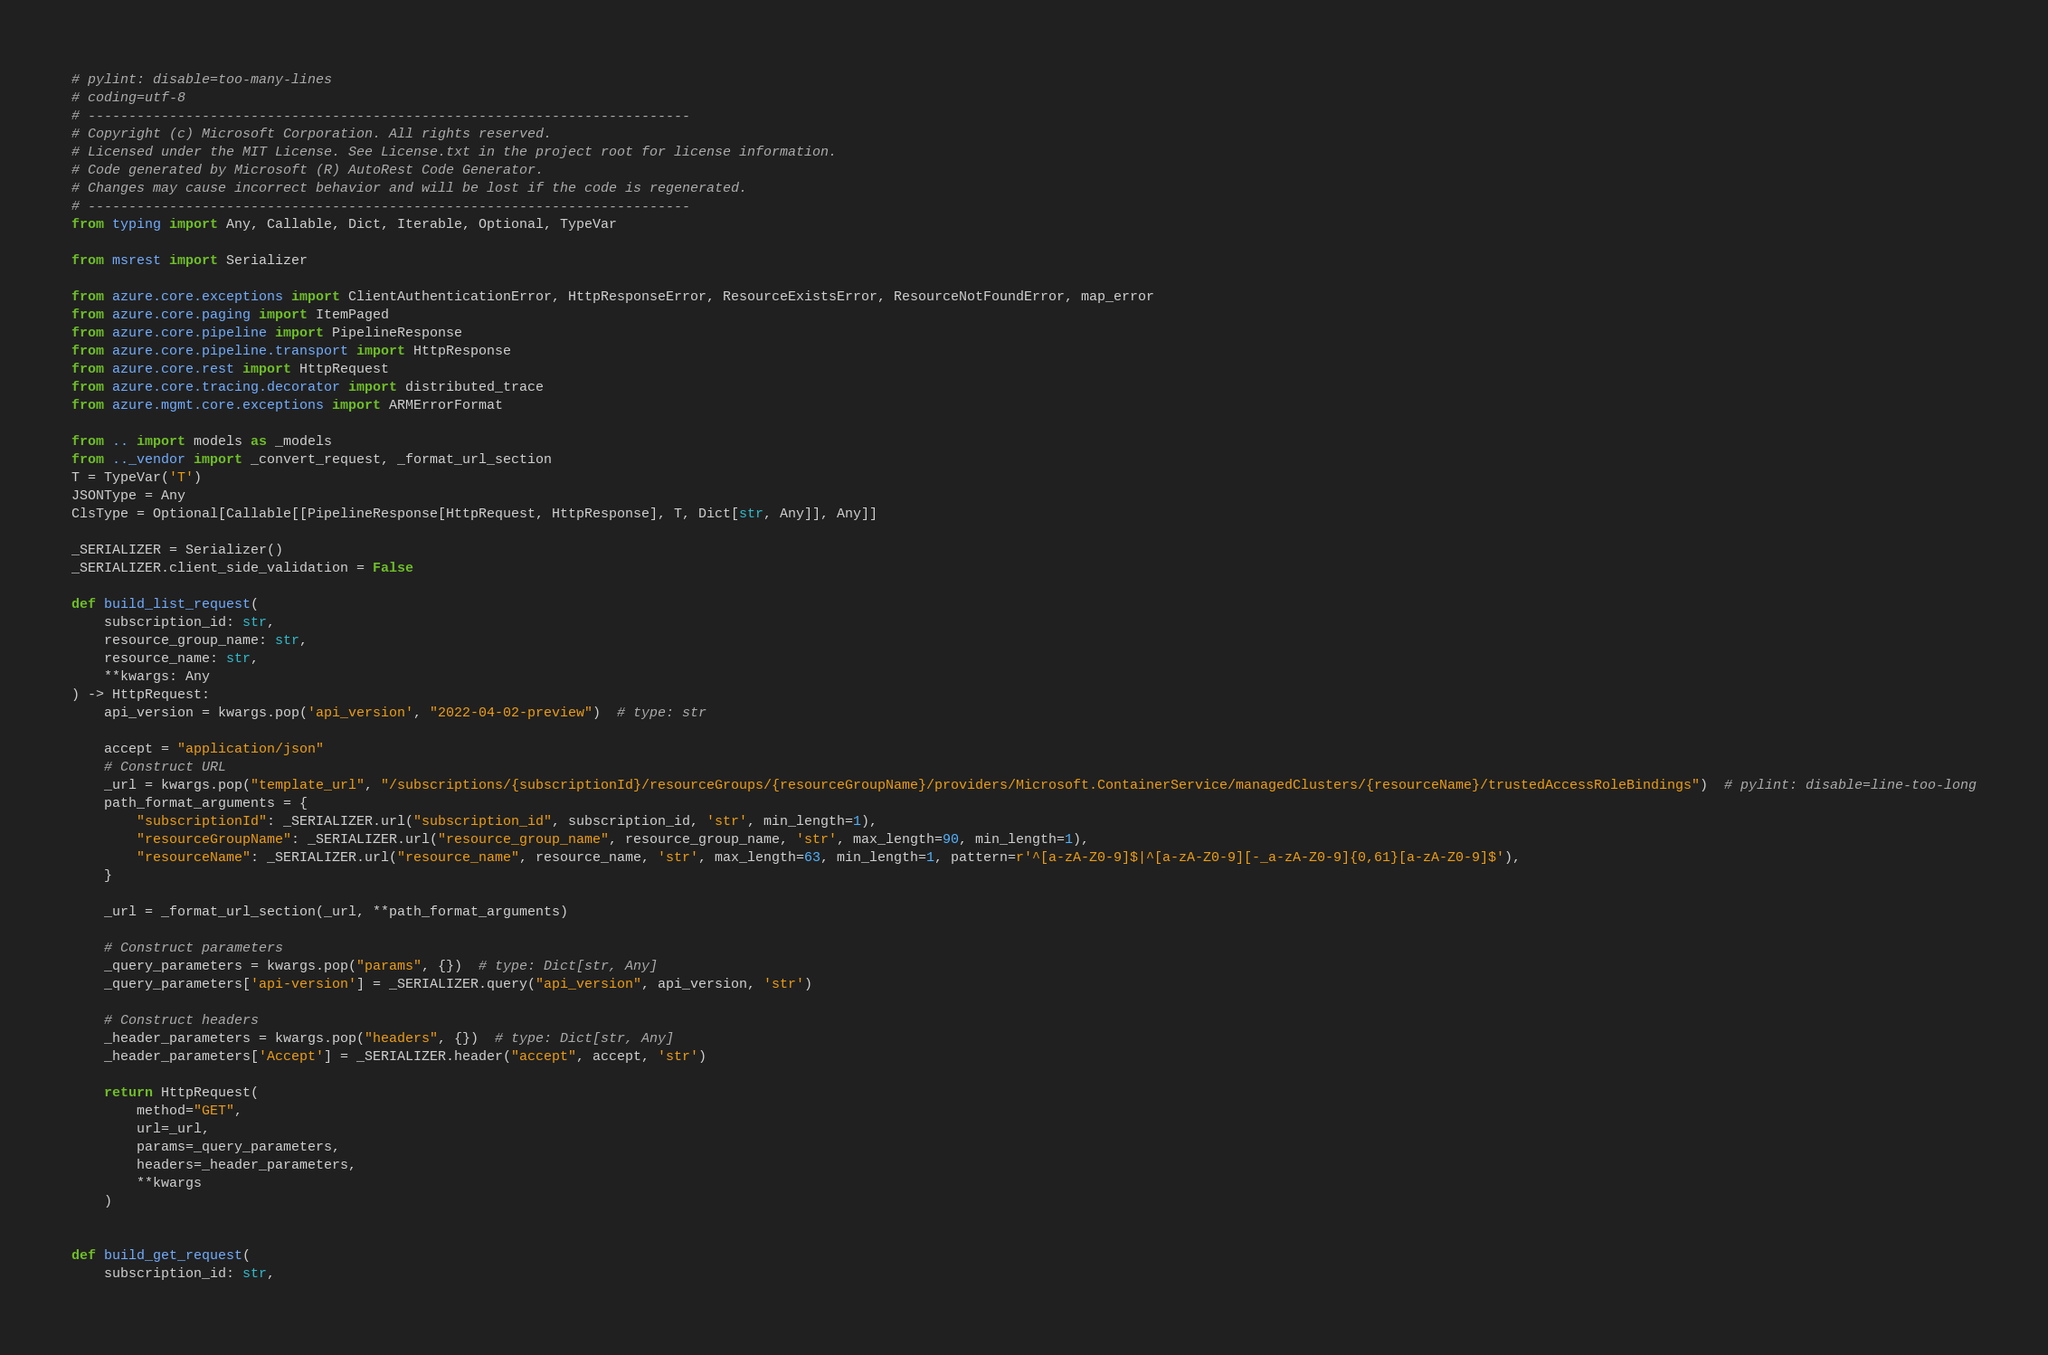Convert code to text. <code><loc_0><loc_0><loc_500><loc_500><_Python_># pylint: disable=too-many-lines
# coding=utf-8
# --------------------------------------------------------------------------
# Copyright (c) Microsoft Corporation. All rights reserved.
# Licensed under the MIT License. See License.txt in the project root for license information.
# Code generated by Microsoft (R) AutoRest Code Generator.
# Changes may cause incorrect behavior and will be lost if the code is regenerated.
# --------------------------------------------------------------------------
from typing import Any, Callable, Dict, Iterable, Optional, TypeVar

from msrest import Serializer

from azure.core.exceptions import ClientAuthenticationError, HttpResponseError, ResourceExistsError, ResourceNotFoundError, map_error
from azure.core.paging import ItemPaged
from azure.core.pipeline import PipelineResponse
from azure.core.pipeline.transport import HttpResponse
from azure.core.rest import HttpRequest
from azure.core.tracing.decorator import distributed_trace
from azure.mgmt.core.exceptions import ARMErrorFormat

from .. import models as _models
from .._vendor import _convert_request, _format_url_section
T = TypeVar('T')
JSONType = Any
ClsType = Optional[Callable[[PipelineResponse[HttpRequest, HttpResponse], T, Dict[str, Any]], Any]]

_SERIALIZER = Serializer()
_SERIALIZER.client_side_validation = False

def build_list_request(
    subscription_id: str,
    resource_group_name: str,
    resource_name: str,
    **kwargs: Any
) -> HttpRequest:
    api_version = kwargs.pop('api_version', "2022-04-02-preview")  # type: str

    accept = "application/json"
    # Construct URL
    _url = kwargs.pop("template_url", "/subscriptions/{subscriptionId}/resourceGroups/{resourceGroupName}/providers/Microsoft.ContainerService/managedClusters/{resourceName}/trustedAccessRoleBindings")  # pylint: disable=line-too-long
    path_format_arguments = {
        "subscriptionId": _SERIALIZER.url("subscription_id", subscription_id, 'str', min_length=1),
        "resourceGroupName": _SERIALIZER.url("resource_group_name", resource_group_name, 'str', max_length=90, min_length=1),
        "resourceName": _SERIALIZER.url("resource_name", resource_name, 'str', max_length=63, min_length=1, pattern=r'^[a-zA-Z0-9]$|^[a-zA-Z0-9][-_a-zA-Z0-9]{0,61}[a-zA-Z0-9]$'),
    }

    _url = _format_url_section(_url, **path_format_arguments)

    # Construct parameters
    _query_parameters = kwargs.pop("params", {})  # type: Dict[str, Any]
    _query_parameters['api-version'] = _SERIALIZER.query("api_version", api_version, 'str')

    # Construct headers
    _header_parameters = kwargs.pop("headers", {})  # type: Dict[str, Any]
    _header_parameters['Accept'] = _SERIALIZER.header("accept", accept, 'str')

    return HttpRequest(
        method="GET",
        url=_url,
        params=_query_parameters,
        headers=_header_parameters,
        **kwargs
    )


def build_get_request(
    subscription_id: str,</code> 